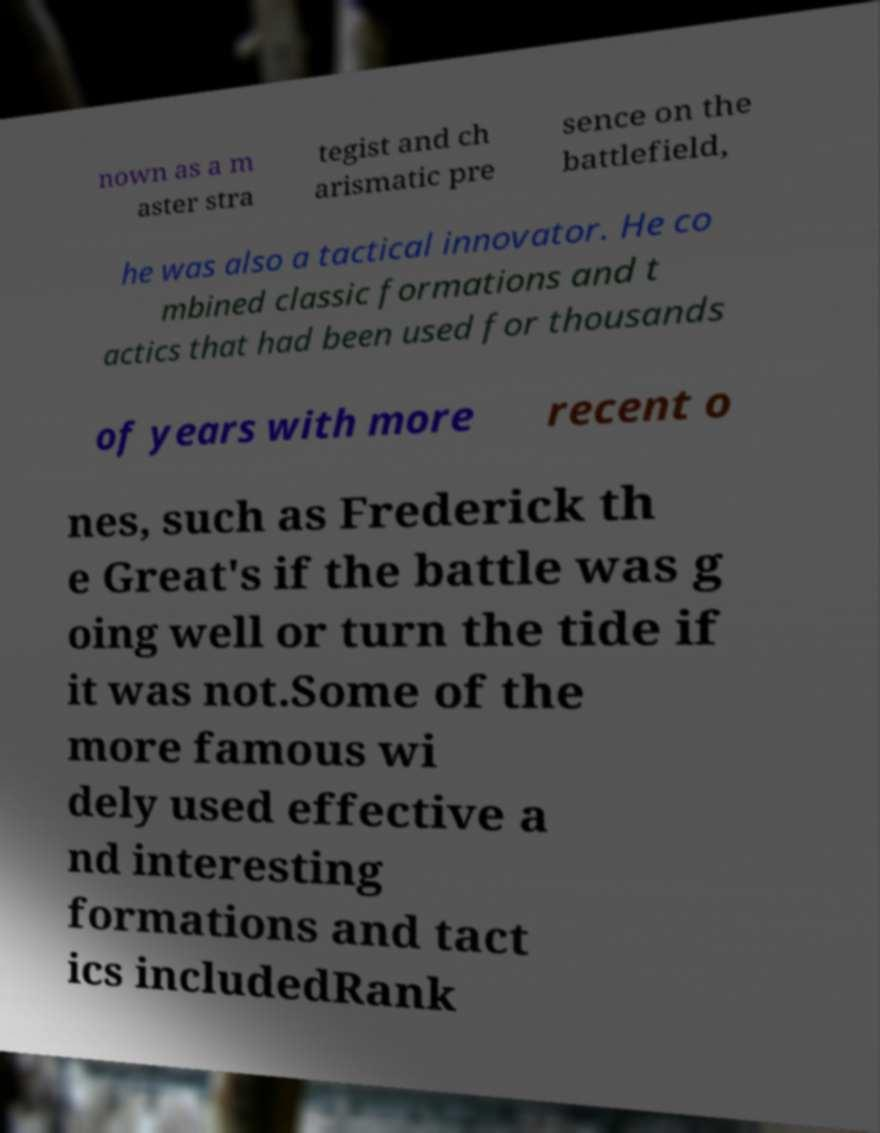Can you read and provide the text displayed in the image?This photo seems to have some interesting text. Can you extract and type it out for me? nown as a m aster stra tegist and ch arismatic pre sence on the battlefield, he was also a tactical innovator. He co mbined classic formations and t actics that had been used for thousands of years with more recent o nes, such as Frederick th e Great's if the battle was g oing well or turn the tide if it was not.Some of the more famous wi dely used effective a nd interesting formations and tact ics includedRank 